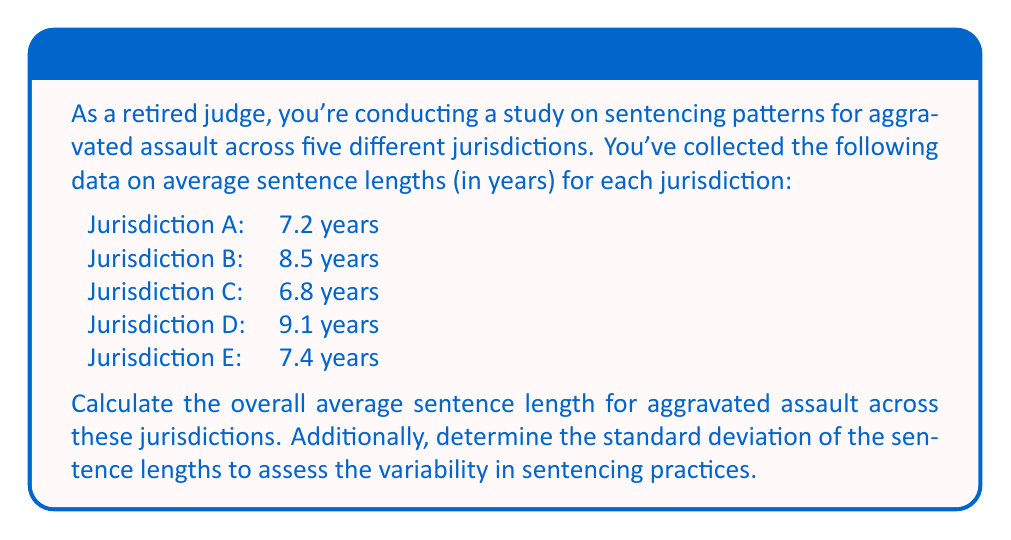Give your solution to this math problem. To solve this problem, we'll follow these steps:

1. Calculate the mean (average) sentence length
2. Calculate the standard deviation of the sentence lengths

Step 1: Calculating the mean sentence length

The formula for the arithmetic mean is:

$$ \bar{x} = \frac{\sum_{i=1}^{n} x_i}{n} $$

Where $\bar{x}$ is the mean, $x_i$ are the individual values, and $n$ is the number of values.

Adding up all the sentence lengths:
$7.2 + 8.5 + 6.8 + 9.1 + 7.4 = 39$

Number of jurisdictions, $n = 5$

Mean sentence length:
$$ \bar{x} = \frac{39}{5} = 7.8 \text{ years} $$

Step 2: Calculating the standard deviation

The formula for standard deviation is:

$$ s = \sqrt{\frac{\sum_{i=1}^{n} (x_i - \bar{x})^2}{n - 1}} $$

Where $s$ is the standard deviation, $x_i$ are the individual values, $\bar{x}$ is the mean, and $n$ is the number of values.

First, we calculate $(x_i - \bar{x})^2$ for each jurisdiction:

Jurisdiction A: $(7.2 - 7.8)^2 = (-0.6)^2 = 0.36$
Jurisdiction B: $(8.5 - 7.8)^2 = (0.7)^2 = 0.49$
Jurisdiction C: $(6.8 - 7.8)^2 = (-1.0)^2 = 1.00$
Jurisdiction D: $(9.1 - 7.8)^2 = (1.3)^2 = 1.69$
Jurisdiction E: $(7.4 - 7.8)^2 = (-0.4)^2 = 0.16$

Sum of these values: $0.36 + 0.49 + 1.00 + 1.69 + 0.16 = 3.70$

Now we can apply the formula:

$$ s = \sqrt{\frac{3.70}{5 - 1}} = \sqrt{0.925} \approx 0.962 \text{ years} $$
Answer: The average sentence length for aggravated assault across the five jurisdictions is 7.8 years, with a standard deviation of approximately 0.962 years. 